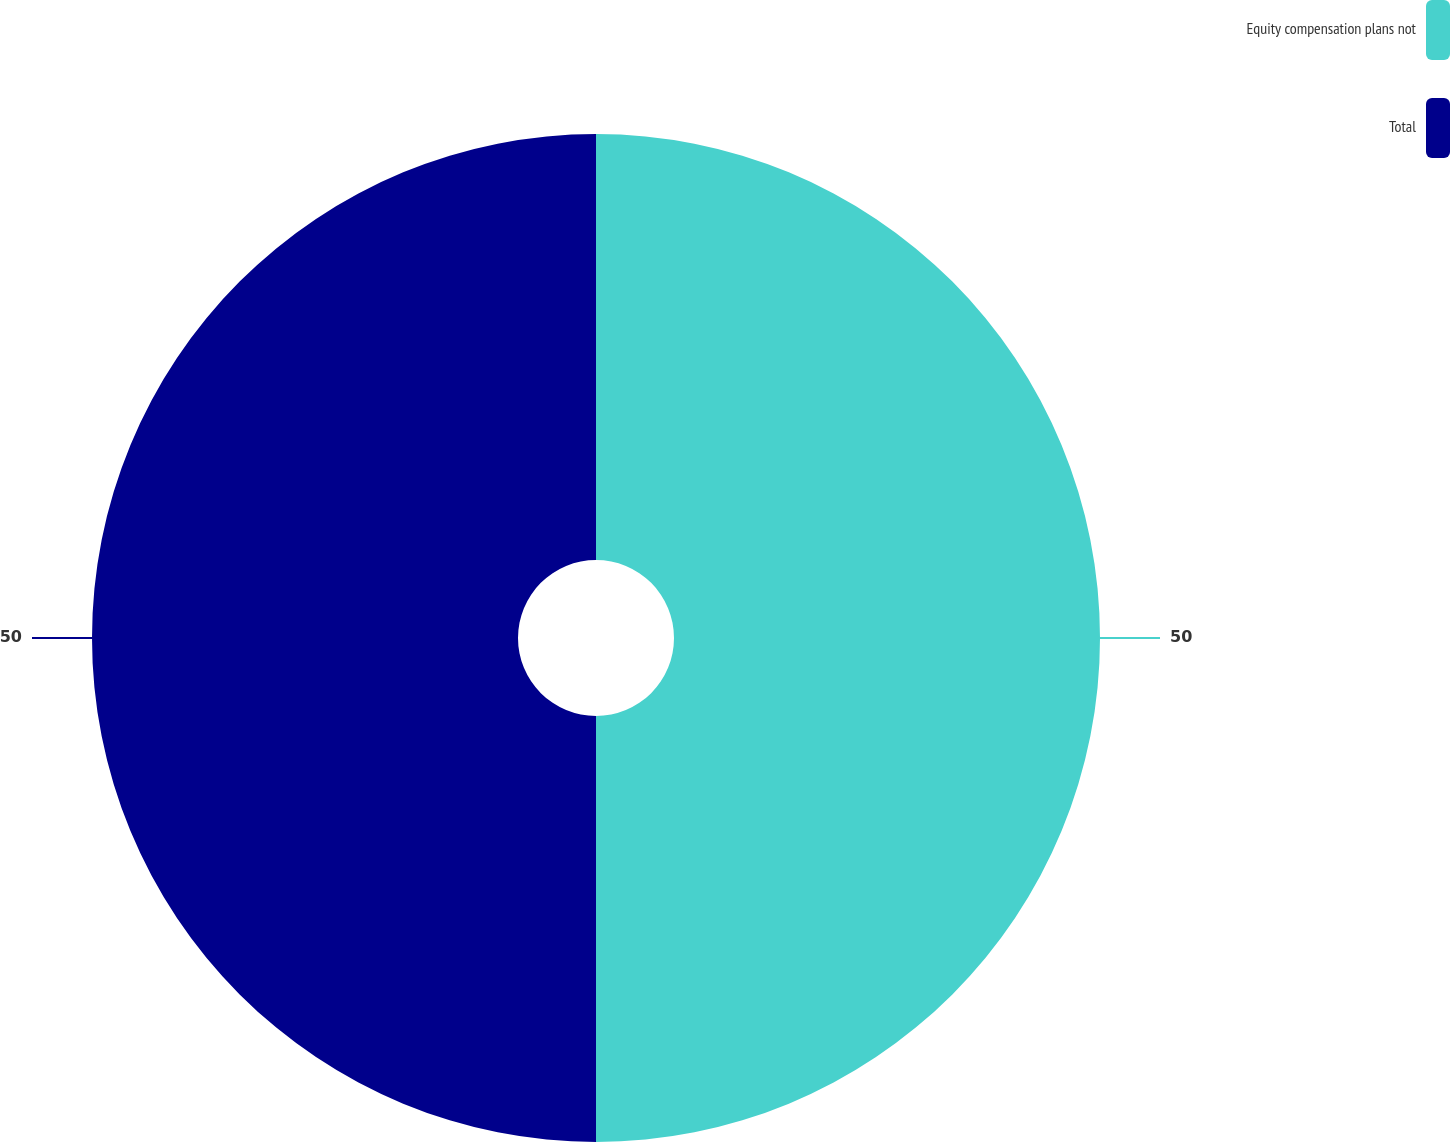Convert chart to OTSL. <chart><loc_0><loc_0><loc_500><loc_500><pie_chart><fcel>Equity compensation plans not<fcel>Total<nl><fcel>50.0%<fcel>50.0%<nl></chart> 